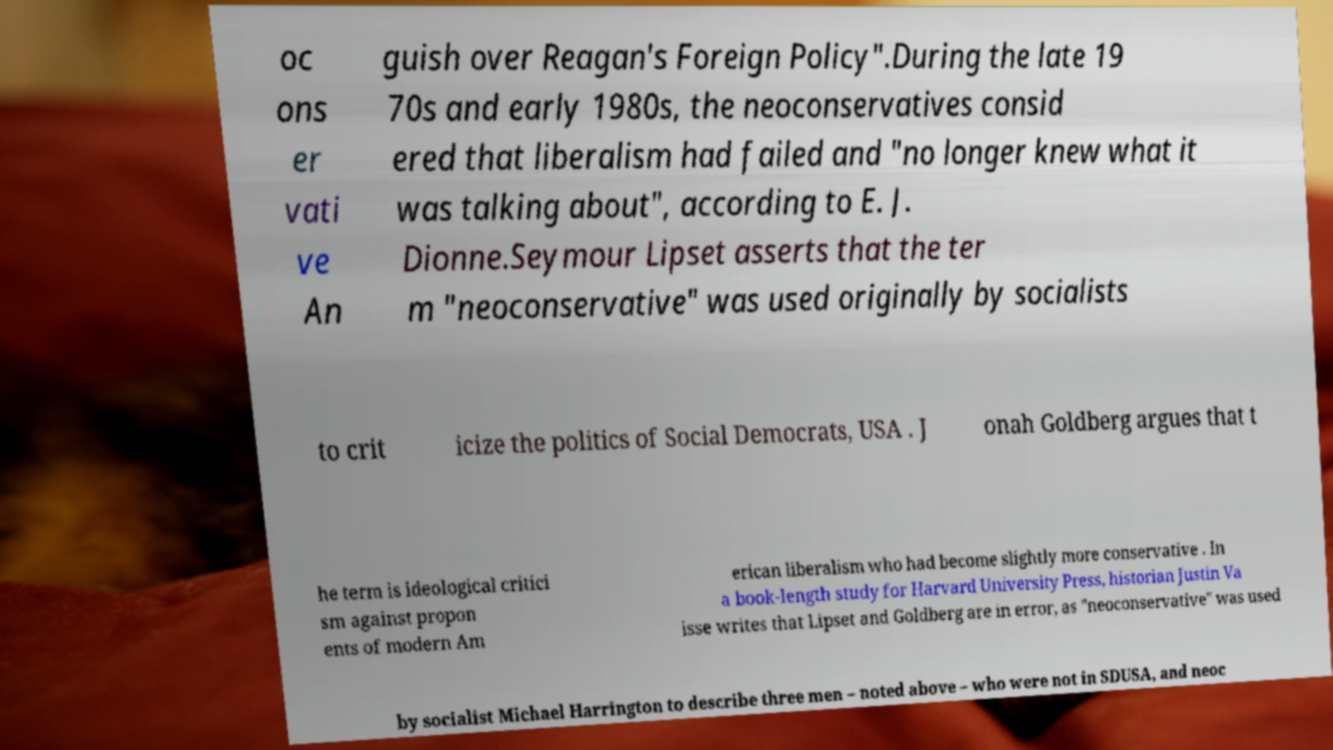There's text embedded in this image that I need extracted. Can you transcribe it verbatim? oc ons er vati ve An guish over Reagan's Foreign Policy".During the late 19 70s and early 1980s, the neoconservatives consid ered that liberalism had failed and "no longer knew what it was talking about", according to E. J. Dionne.Seymour Lipset asserts that the ter m "neoconservative" was used originally by socialists to crit icize the politics of Social Democrats, USA . J onah Goldberg argues that t he term is ideological critici sm against propon ents of modern Am erican liberalism who had become slightly more conservative . In a book-length study for Harvard University Press, historian Justin Va isse writes that Lipset and Goldberg are in error, as "neoconservative" was used by socialist Michael Harrington to describe three men – noted above – who were not in SDUSA, and neoc 